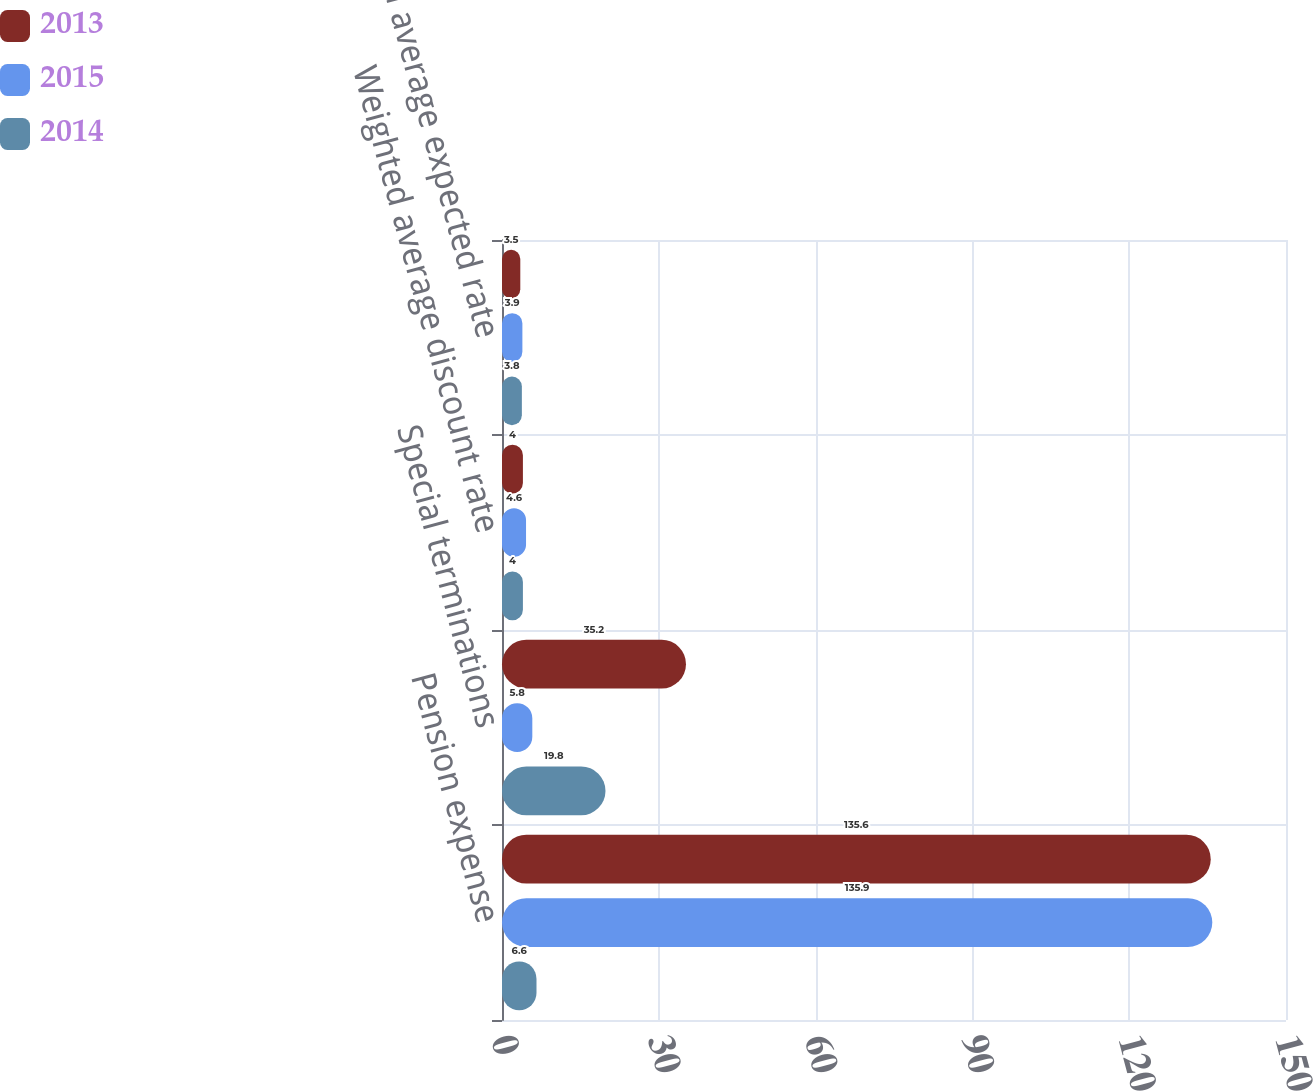Convert chart to OTSL. <chart><loc_0><loc_0><loc_500><loc_500><stacked_bar_chart><ecel><fcel>Pension expense<fcel>Special terminations<fcel>Weighted average discount rate<fcel>Weighted average expected rate<nl><fcel>2013<fcel>135.6<fcel>35.2<fcel>4<fcel>3.5<nl><fcel>2015<fcel>135.9<fcel>5.8<fcel>4.6<fcel>3.9<nl><fcel>2014<fcel>6.6<fcel>19.8<fcel>4<fcel>3.8<nl></chart> 